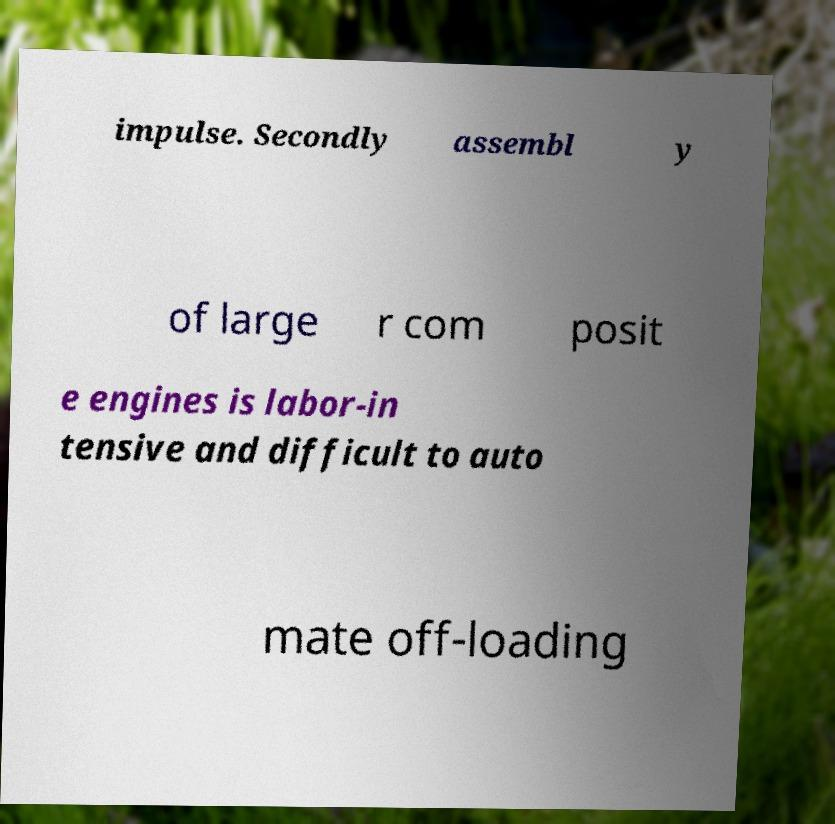There's text embedded in this image that I need extracted. Can you transcribe it verbatim? impulse. Secondly assembl y of large r com posit e engines is labor-in tensive and difficult to auto mate off-loading 